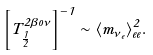Convert formula to latex. <formula><loc_0><loc_0><loc_500><loc_500>\left [ T _ { \frac { 1 } { 2 } } ^ { 2 \beta o \nu } \right ] ^ { - 1 } \sim \langle m _ { \nu _ { e } } \rangle _ { e e } ^ { 2 } .</formula> 